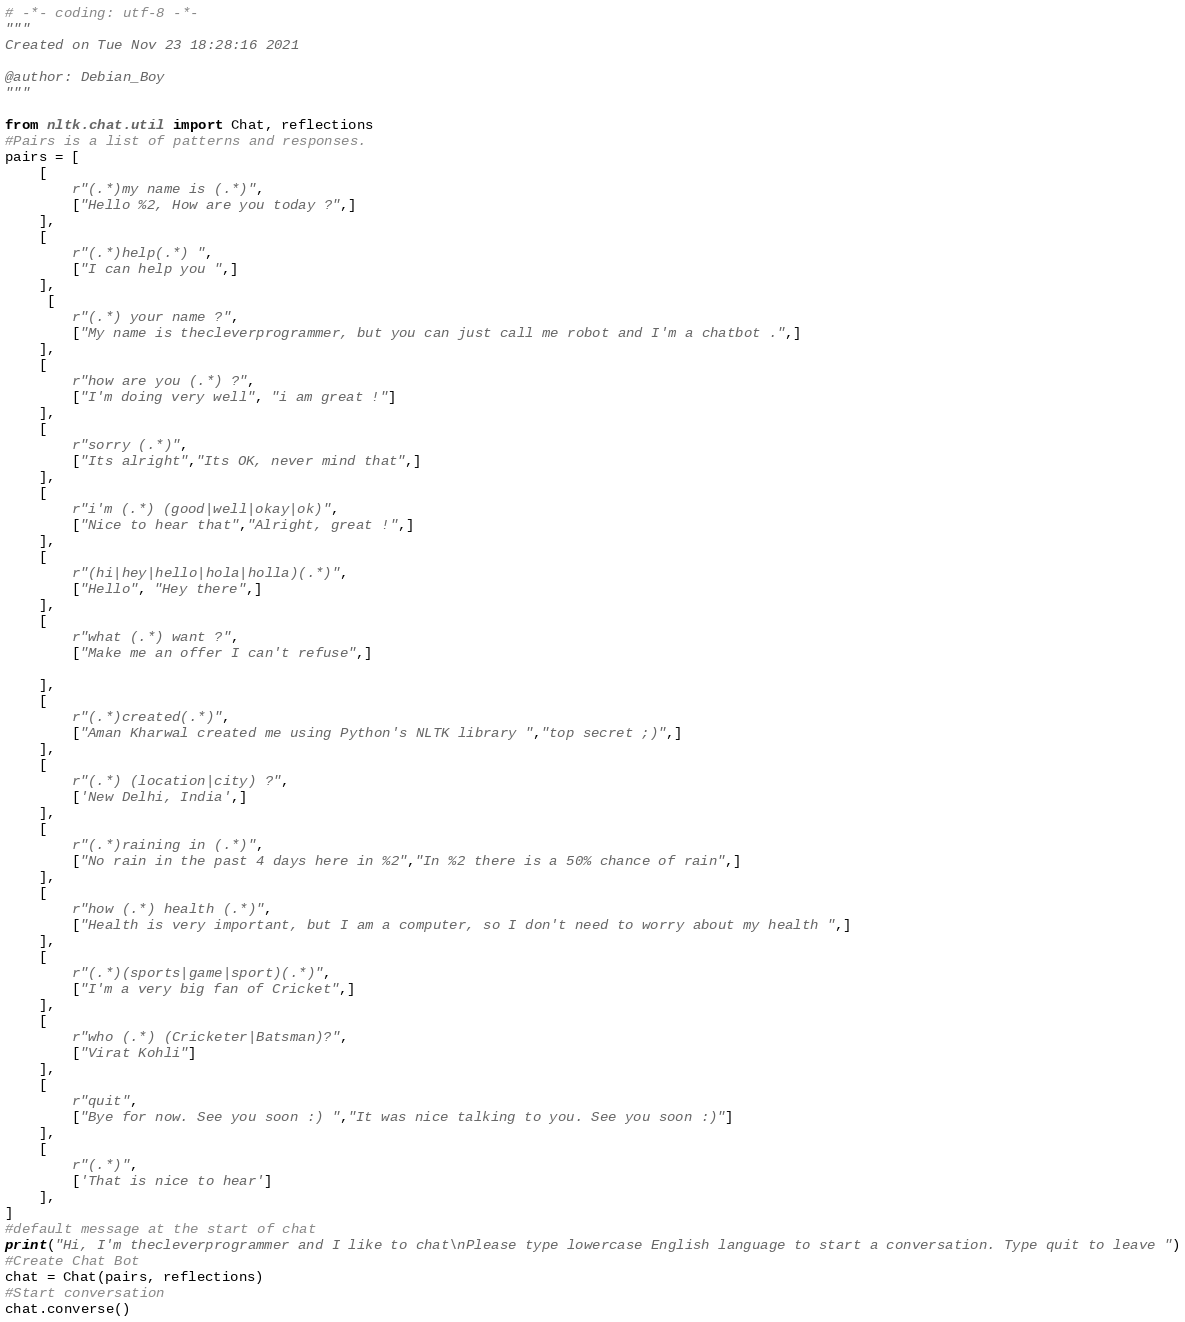<code> <loc_0><loc_0><loc_500><loc_500><_Python_># -*- coding: utf-8 -*-
"""
Created on Tue Nov 23 18:28:16 2021

@author: Debian_Boy
"""

from nltk.chat.util import Chat, reflections
#Pairs is a list of patterns and responses.
pairs = [
    [
        r"(.*)my name is (.*)",
        ["Hello %2, How are you today ?",]
    ],
    [
        r"(.*)help(.*) ",
        ["I can help you ",]
    ],
     [
        r"(.*) your name ?",
        ["My name is thecleverprogrammer, but you can just call me robot and I'm a chatbot .",]
    ],
    [
        r"how are you (.*) ?",
        ["I'm doing very well", "i am great !"]
    ],
    [
        r"sorry (.*)",
        ["Its alright","Its OK, never mind that",]
    ],
    [
        r"i'm (.*) (good|well|okay|ok)",
        ["Nice to hear that","Alright, great !",]
    ],
    [
        r"(hi|hey|hello|hola|holla)(.*)",
        ["Hello", "Hey there",]
    ],
    [
        r"what (.*) want ?",
        ["Make me an offer I can't refuse",]
        
    ],
    [
        r"(.*)created(.*)",
        ["Aman Kharwal created me using Python's NLTK library ","top secret ;)",]
    ],
    [
        r"(.*) (location|city) ?",
        ['New Delhi, India',]
    ],
    [
        r"(.*)raining in (.*)",
        ["No rain in the past 4 days here in %2","In %2 there is a 50% chance of rain",]
    ],
    [
        r"how (.*) health (.*)",
        ["Health is very important, but I am a computer, so I don't need to worry about my health ",]
    ],
    [
        r"(.*)(sports|game|sport)(.*)",
        ["I'm a very big fan of Cricket",]
    ],
    [
        r"who (.*) (Cricketer|Batsman)?",
        ["Virat Kohli"]
    ],
    [
        r"quit",
        ["Bye for now. See you soon :) ","It was nice talking to you. See you soon :)"]
    ],
    [
        r"(.*)",
        ['That is nice to hear']
    ],
]
#default message at the start of chat
print("Hi, I'm thecleverprogrammer and I like to chat\nPlease type lowercase English language to start a conversation. Type quit to leave ")
#Create Chat Bot
chat = Chat(pairs, reflections)
#Start conversation
chat.converse()</code> 